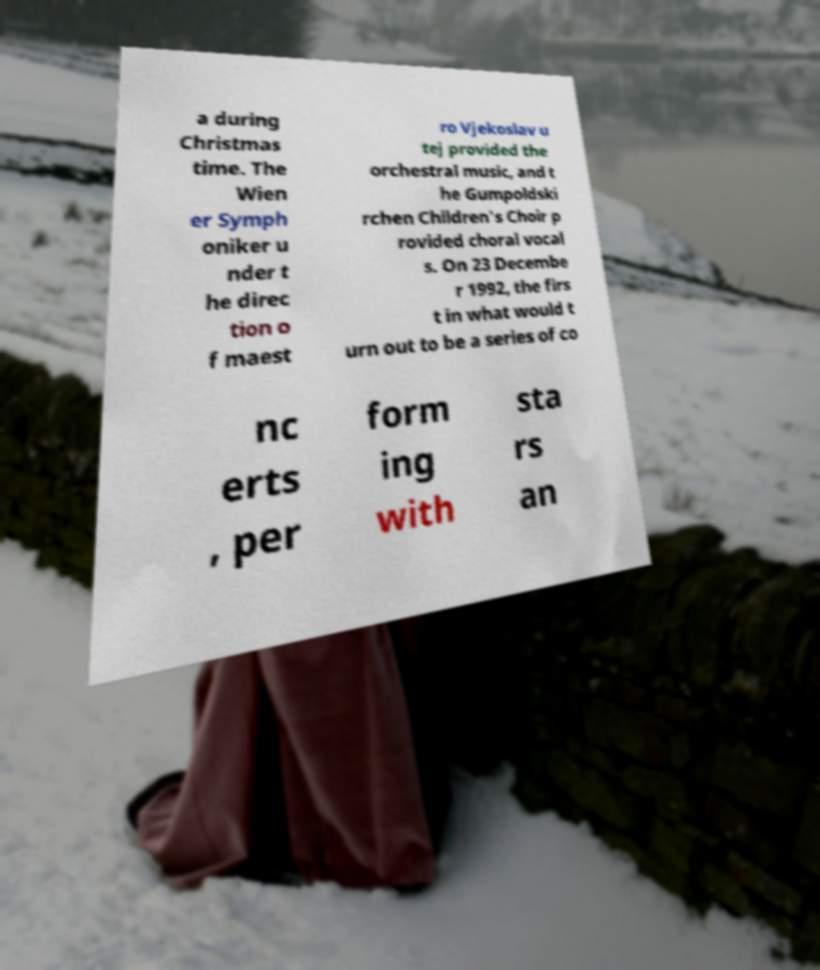Can you read and provide the text displayed in the image?This photo seems to have some interesting text. Can you extract and type it out for me? a during Christmas time. The Wien er Symph oniker u nder t he direc tion o f maest ro Vjekoslav u tej provided the orchestral music, and t he Gumpoldski rchen Children's Choir p rovided choral vocal s. On 23 Decembe r 1992, the firs t in what would t urn out to be a series of co nc erts , per form ing with sta rs an 